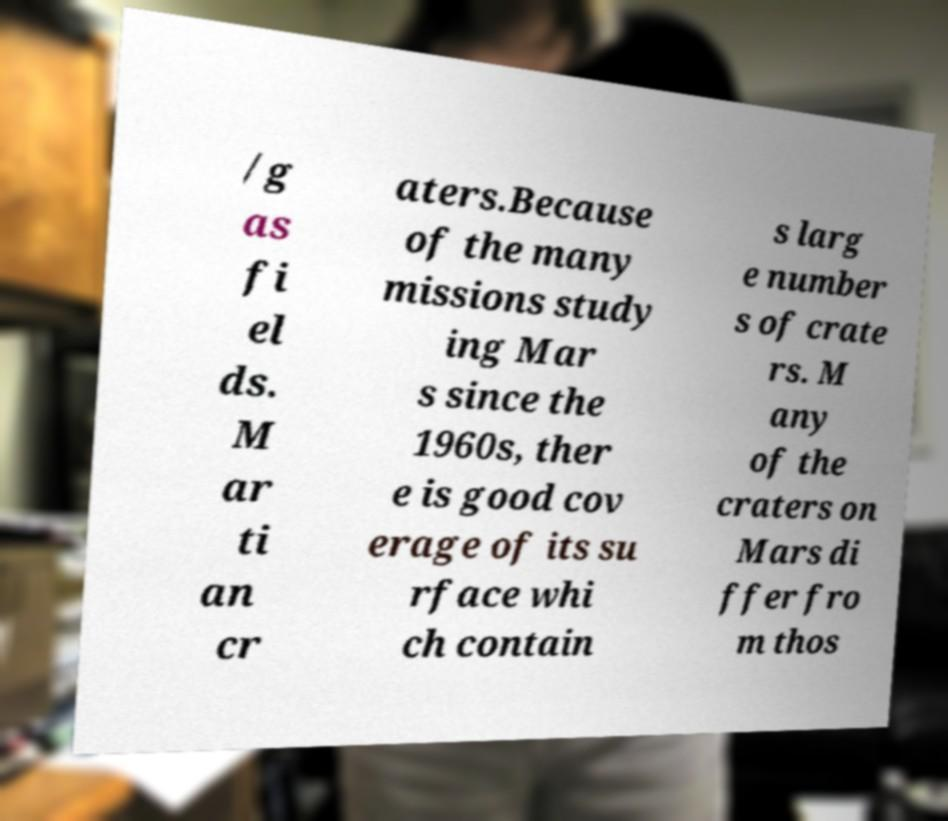Could you assist in decoding the text presented in this image and type it out clearly? /g as fi el ds. M ar ti an cr aters.Because of the many missions study ing Mar s since the 1960s, ther e is good cov erage of its su rface whi ch contain s larg e number s of crate rs. M any of the craters on Mars di ffer fro m thos 